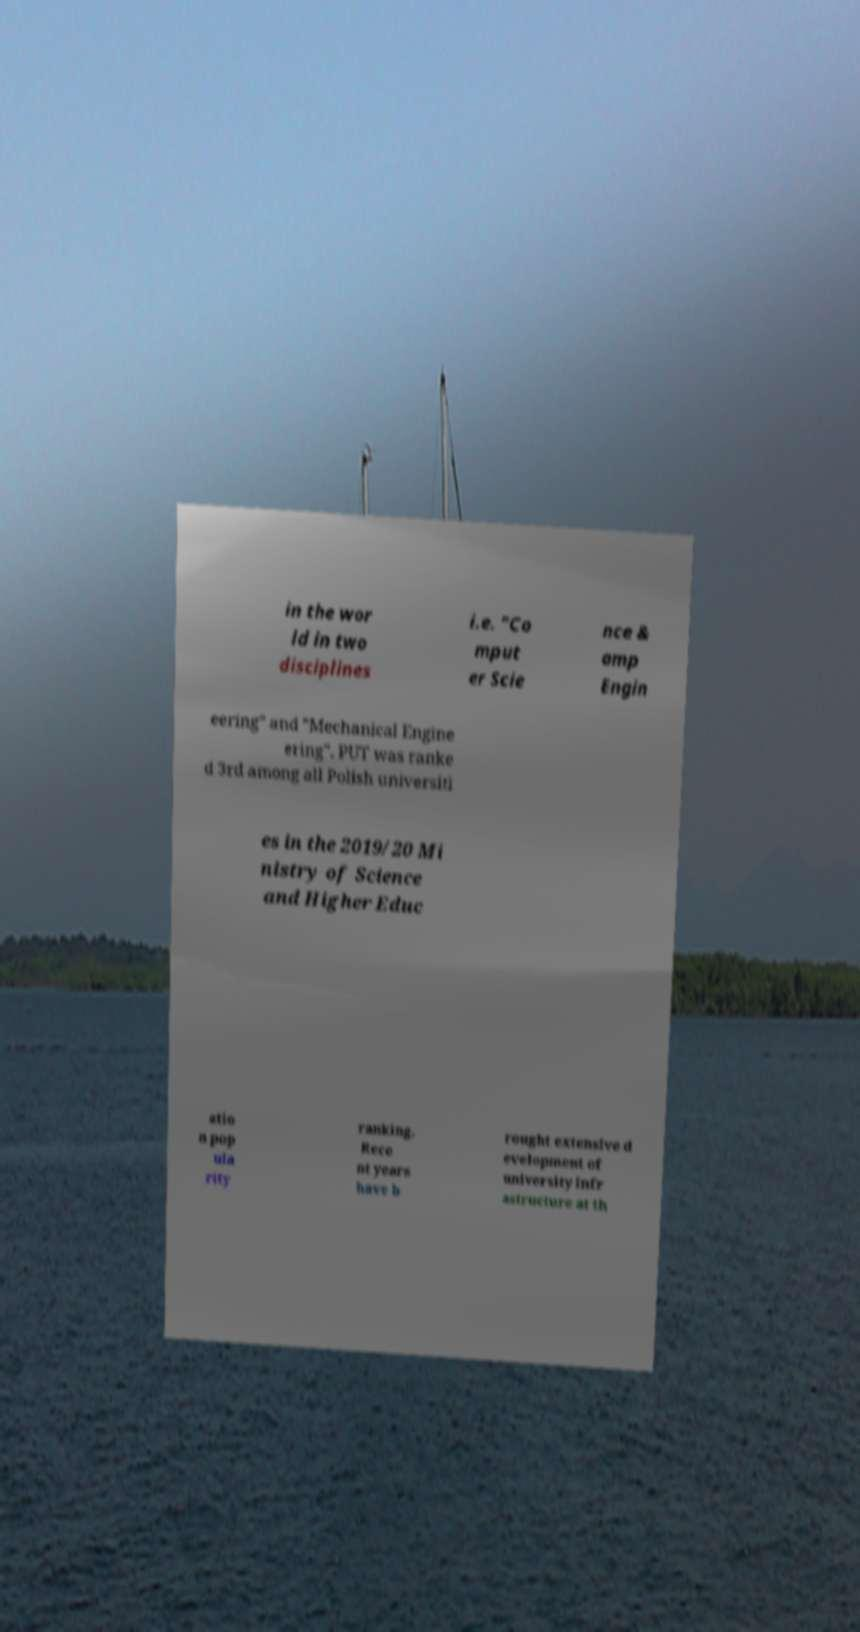I need the written content from this picture converted into text. Can you do that? in the wor ld in two disciplines i.e. "Co mput er Scie nce & amp Engin eering" and "Mechanical Engine ering". PUT was ranke d 3rd among all Polish universiti es in the 2019/20 Mi nistry of Science and Higher Educ atio n pop ula rity ranking. Rece nt years have b rought extensive d evelopment of university infr astructure at th 